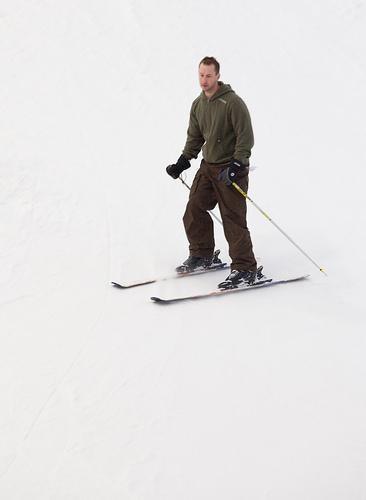How many people in the photo?
Give a very brief answer. 1. 